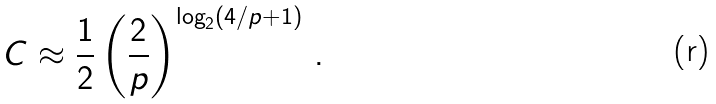Convert formula to latex. <formula><loc_0><loc_0><loc_500><loc_500>C \approx \frac { 1 } { 2 } \left ( \frac { 2 } { p } \right ) ^ { \log _ { 2 } ( 4 / p + 1 ) } \, .</formula> 